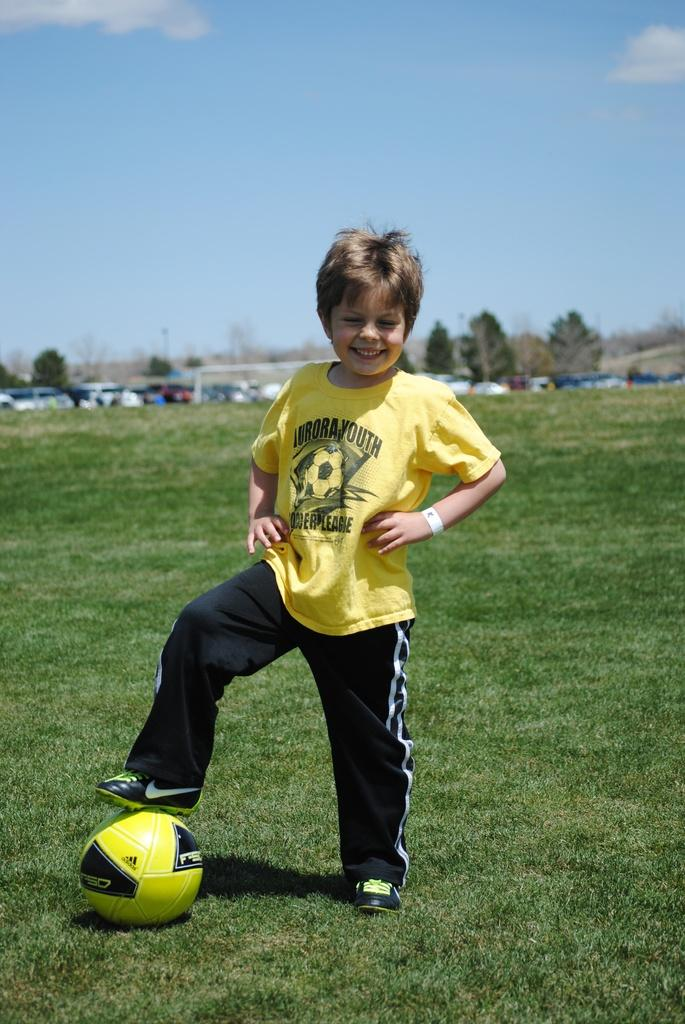Provide a one-sentence caption for the provided image. A boy in an Aurora Youth shirt stands with one foot up on a soccer ball. 